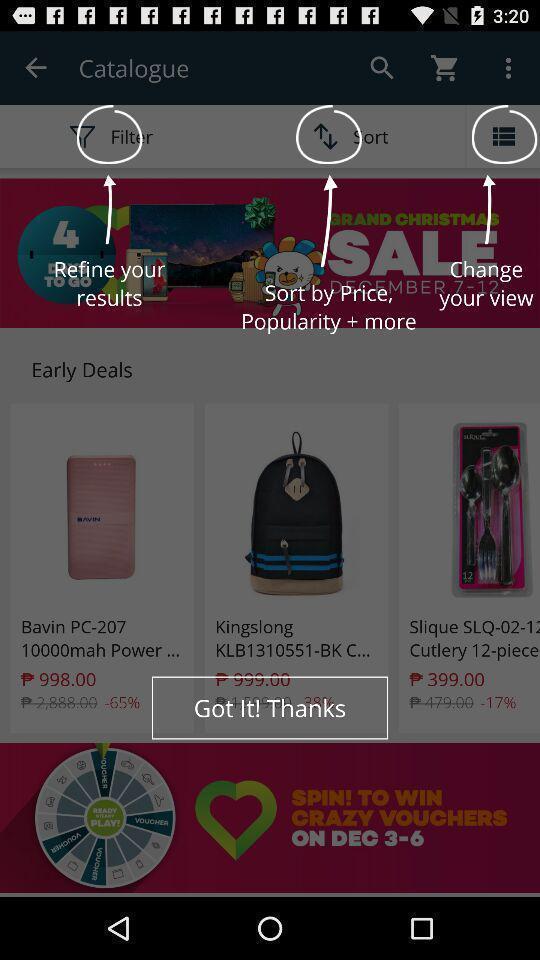What is the overall content of this screenshot? Web page shows various icons in an ecommerce site. 